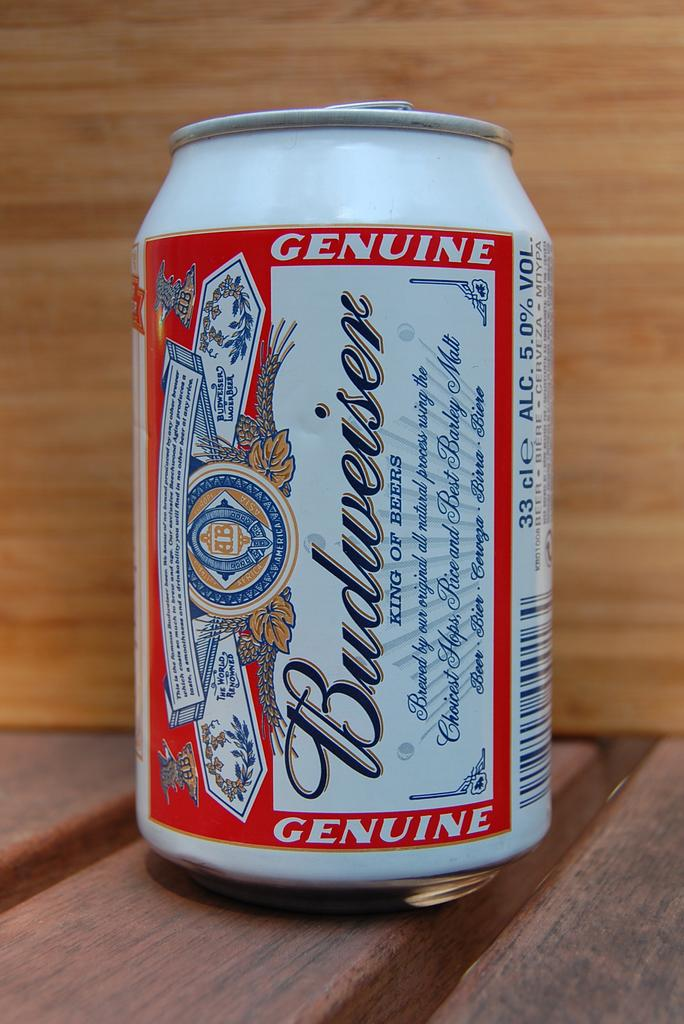<image>
Describe the image concisely. A can of beer made by Budweiser sits atop a wood surface. 